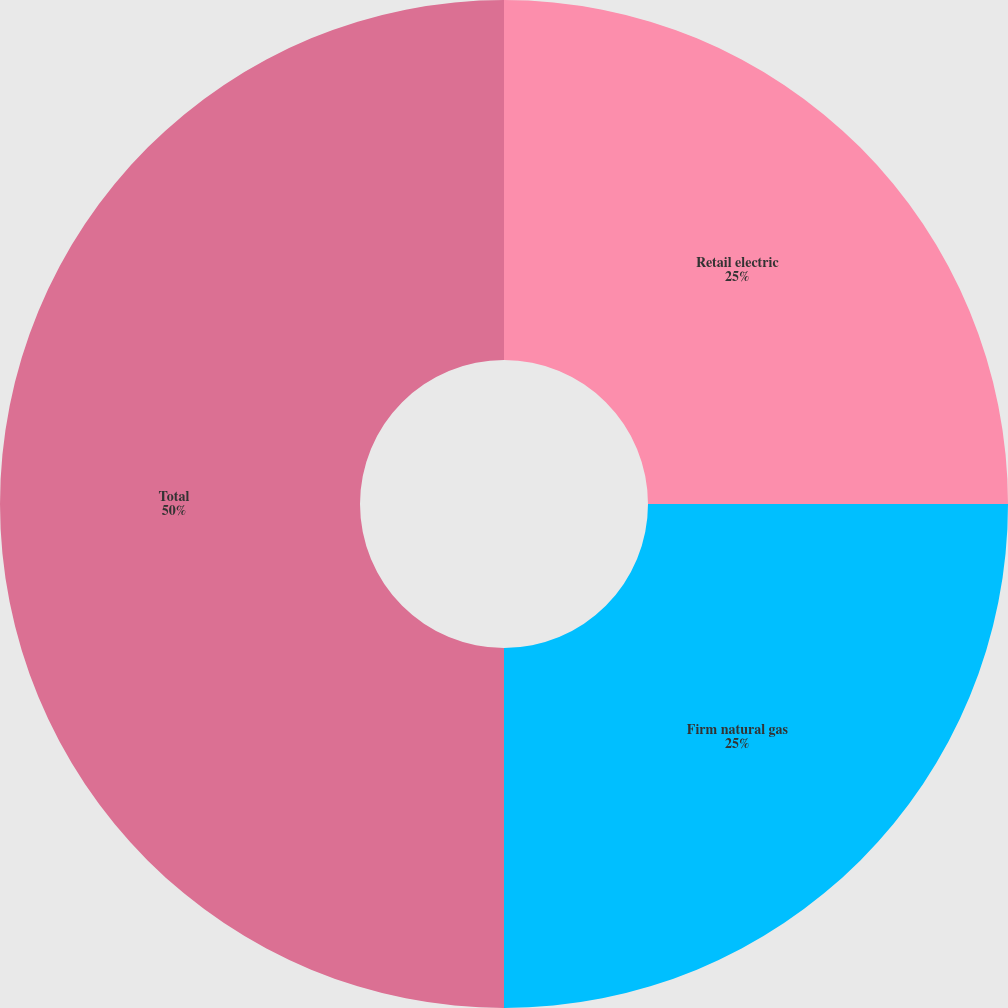Convert chart. <chart><loc_0><loc_0><loc_500><loc_500><pie_chart><fcel>Retail electric<fcel>Firm natural gas<fcel>Total<nl><fcel>25.0%<fcel>25.0%<fcel>50.0%<nl></chart> 